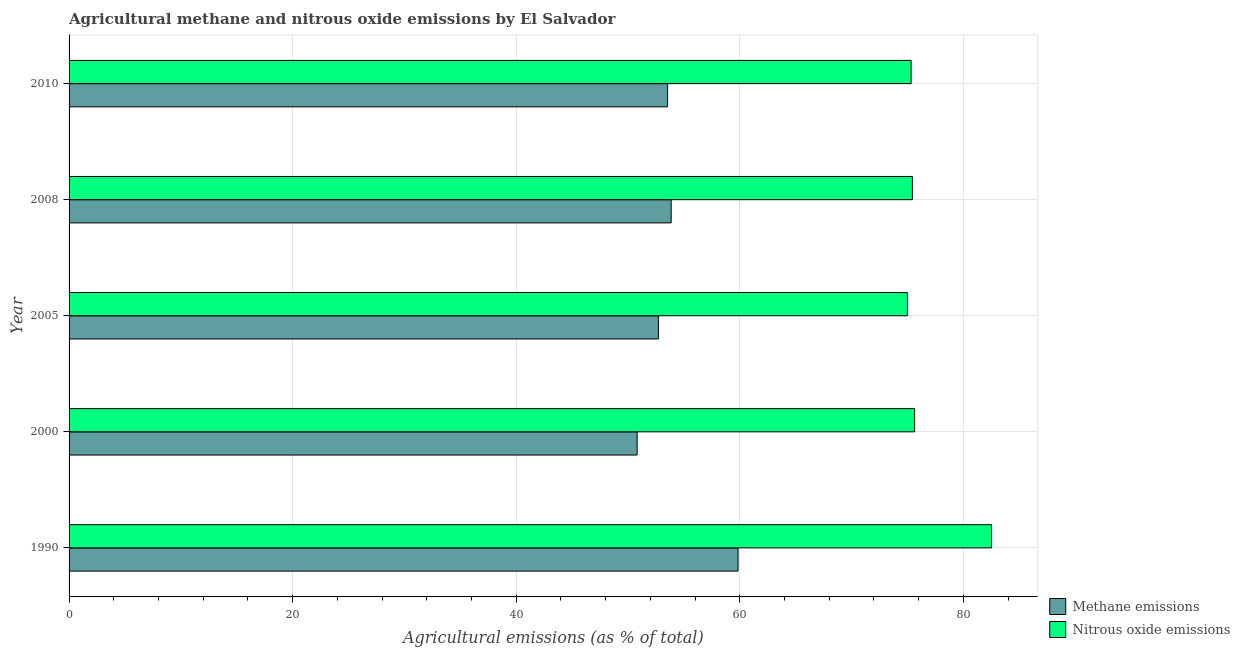How many groups of bars are there?
Provide a succinct answer. 5. Are the number of bars per tick equal to the number of legend labels?
Your response must be concise. Yes. Are the number of bars on each tick of the Y-axis equal?
Offer a very short reply. Yes. How many bars are there on the 3rd tick from the top?
Give a very brief answer. 2. What is the label of the 1st group of bars from the top?
Your response must be concise. 2010. In how many cases, is the number of bars for a given year not equal to the number of legend labels?
Your response must be concise. 0. What is the amount of methane emissions in 2010?
Your answer should be compact. 53.54. Across all years, what is the maximum amount of methane emissions?
Provide a short and direct response. 59.84. Across all years, what is the minimum amount of nitrous oxide emissions?
Offer a very short reply. 74.99. In which year was the amount of methane emissions minimum?
Offer a terse response. 2000. What is the total amount of nitrous oxide emissions in the graph?
Give a very brief answer. 383.91. What is the difference between the amount of nitrous oxide emissions in 2005 and the amount of methane emissions in 2008?
Give a very brief answer. 21.13. What is the average amount of methane emissions per year?
Your answer should be very brief. 54.16. In the year 2005, what is the difference between the amount of methane emissions and amount of nitrous oxide emissions?
Make the answer very short. -22.28. In how many years, is the amount of methane emissions greater than 20 %?
Your answer should be very brief. 5. What is the ratio of the amount of methane emissions in 1990 to that in 2010?
Offer a terse response. 1.12. Is the difference between the amount of nitrous oxide emissions in 1990 and 2010 greater than the difference between the amount of methane emissions in 1990 and 2010?
Keep it short and to the point. Yes. What is the difference between the highest and the second highest amount of methane emissions?
Your response must be concise. 5.98. What is the difference between the highest and the lowest amount of nitrous oxide emissions?
Offer a very short reply. 7.53. In how many years, is the amount of methane emissions greater than the average amount of methane emissions taken over all years?
Your answer should be compact. 1. Is the sum of the amount of methane emissions in 1990 and 2010 greater than the maximum amount of nitrous oxide emissions across all years?
Offer a terse response. Yes. What does the 2nd bar from the top in 2008 represents?
Offer a very short reply. Methane emissions. What does the 2nd bar from the bottom in 2000 represents?
Your answer should be very brief. Nitrous oxide emissions. Are the values on the major ticks of X-axis written in scientific E-notation?
Your response must be concise. No. Does the graph contain any zero values?
Provide a short and direct response. No. Does the graph contain grids?
Your response must be concise. Yes. How many legend labels are there?
Your answer should be compact. 2. How are the legend labels stacked?
Keep it short and to the point. Vertical. What is the title of the graph?
Your response must be concise. Agricultural methane and nitrous oxide emissions by El Salvador. Does "Foreign liabilities" appear as one of the legend labels in the graph?
Your answer should be compact. No. What is the label or title of the X-axis?
Your response must be concise. Agricultural emissions (as % of total). What is the label or title of the Y-axis?
Offer a very short reply. Year. What is the Agricultural emissions (as % of total) in Methane emissions in 1990?
Your response must be concise. 59.84. What is the Agricultural emissions (as % of total) of Nitrous oxide emissions in 1990?
Make the answer very short. 82.52. What is the Agricultural emissions (as % of total) in Methane emissions in 2000?
Ensure brevity in your answer.  50.82. What is the Agricultural emissions (as % of total) of Nitrous oxide emissions in 2000?
Ensure brevity in your answer.  75.64. What is the Agricultural emissions (as % of total) in Methane emissions in 2005?
Your answer should be very brief. 52.72. What is the Agricultural emissions (as % of total) of Nitrous oxide emissions in 2005?
Offer a very short reply. 74.99. What is the Agricultural emissions (as % of total) in Methane emissions in 2008?
Your answer should be compact. 53.86. What is the Agricultural emissions (as % of total) in Nitrous oxide emissions in 2008?
Offer a terse response. 75.44. What is the Agricultural emissions (as % of total) in Methane emissions in 2010?
Your answer should be very brief. 53.54. What is the Agricultural emissions (as % of total) of Nitrous oxide emissions in 2010?
Provide a short and direct response. 75.32. Across all years, what is the maximum Agricultural emissions (as % of total) in Methane emissions?
Your answer should be compact. 59.84. Across all years, what is the maximum Agricultural emissions (as % of total) in Nitrous oxide emissions?
Provide a succinct answer. 82.52. Across all years, what is the minimum Agricultural emissions (as % of total) in Methane emissions?
Offer a terse response. 50.82. Across all years, what is the minimum Agricultural emissions (as % of total) in Nitrous oxide emissions?
Offer a very short reply. 74.99. What is the total Agricultural emissions (as % of total) of Methane emissions in the graph?
Give a very brief answer. 270.78. What is the total Agricultural emissions (as % of total) in Nitrous oxide emissions in the graph?
Keep it short and to the point. 383.91. What is the difference between the Agricultural emissions (as % of total) of Methane emissions in 1990 and that in 2000?
Give a very brief answer. 9.02. What is the difference between the Agricultural emissions (as % of total) of Nitrous oxide emissions in 1990 and that in 2000?
Make the answer very short. 6.88. What is the difference between the Agricultural emissions (as % of total) in Methane emissions in 1990 and that in 2005?
Provide a succinct answer. 7.12. What is the difference between the Agricultural emissions (as % of total) in Nitrous oxide emissions in 1990 and that in 2005?
Give a very brief answer. 7.53. What is the difference between the Agricultural emissions (as % of total) of Methane emissions in 1990 and that in 2008?
Offer a terse response. 5.98. What is the difference between the Agricultural emissions (as % of total) of Nitrous oxide emissions in 1990 and that in 2008?
Ensure brevity in your answer.  7.09. What is the difference between the Agricultural emissions (as % of total) of Methane emissions in 1990 and that in 2010?
Offer a very short reply. 6.3. What is the difference between the Agricultural emissions (as % of total) in Nitrous oxide emissions in 1990 and that in 2010?
Provide a succinct answer. 7.2. What is the difference between the Agricultural emissions (as % of total) in Methane emissions in 2000 and that in 2005?
Keep it short and to the point. -1.9. What is the difference between the Agricultural emissions (as % of total) of Nitrous oxide emissions in 2000 and that in 2005?
Your answer should be very brief. 0.64. What is the difference between the Agricultural emissions (as % of total) in Methane emissions in 2000 and that in 2008?
Offer a very short reply. -3.04. What is the difference between the Agricultural emissions (as % of total) in Nitrous oxide emissions in 2000 and that in 2008?
Make the answer very short. 0.2. What is the difference between the Agricultural emissions (as % of total) in Methane emissions in 2000 and that in 2010?
Your answer should be very brief. -2.72. What is the difference between the Agricultural emissions (as % of total) in Nitrous oxide emissions in 2000 and that in 2010?
Your response must be concise. 0.32. What is the difference between the Agricultural emissions (as % of total) in Methane emissions in 2005 and that in 2008?
Offer a very short reply. -1.14. What is the difference between the Agricultural emissions (as % of total) in Nitrous oxide emissions in 2005 and that in 2008?
Provide a succinct answer. -0.44. What is the difference between the Agricultural emissions (as % of total) of Methane emissions in 2005 and that in 2010?
Your answer should be compact. -0.82. What is the difference between the Agricultural emissions (as % of total) of Nitrous oxide emissions in 2005 and that in 2010?
Offer a very short reply. -0.33. What is the difference between the Agricultural emissions (as % of total) of Methane emissions in 2008 and that in 2010?
Give a very brief answer. 0.32. What is the difference between the Agricultural emissions (as % of total) in Nitrous oxide emissions in 2008 and that in 2010?
Offer a terse response. 0.11. What is the difference between the Agricultural emissions (as % of total) of Methane emissions in 1990 and the Agricultural emissions (as % of total) of Nitrous oxide emissions in 2000?
Your response must be concise. -15.8. What is the difference between the Agricultural emissions (as % of total) in Methane emissions in 1990 and the Agricultural emissions (as % of total) in Nitrous oxide emissions in 2005?
Keep it short and to the point. -15.15. What is the difference between the Agricultural emissions (as % of total) of Methane emissions in 1990 and the Agricultural emissions (as % of total) of Nitrous oxide emissions in 2008?
Make the answer very short. -15.59. What is the difference between the Agricultural emissions (as % of total) of Methane emissions in 1990 and the Agricultural emissions (as % of total) of Nitrous oxide emissions in 2010?
Offer a very short reply. -15.48. What is the difference between the Agricultural emissions (as % of total) in Methane emissions in 2000 and the Agricultural emissions (as % of total) in Nitrous oxide emissions in 2005?
Offer a terse response. -24.18. What is the difference between the Agricultural emissions (as % of total) of Methane emissions in 2000 and the Agricultural emissions (as % of total) of Nitrous oxide emissions in 2008?
Offer a very short reply. -24.62. What is the difference between the Agricultural emissions (as % of total) of Methane emissions in 2000 and the Agricultural emissions (as % of total) of Nitrous oxide emissions in 2010?
Keep it short and to the point. -24.51. What is the difference between the Agricultural emissions (as % of total) in Methane emissions in 2005 and the Agricultural emissions (as % of total) in Nitrous oxide emissions in 2008?
Provide a succinct answer. -22.72. What is the difference between the Agricultural emissions (as % of total) of Methane emissions in 2005 and the Agricultural emissions (as % of total) of Nitrous oxide emissions in 2010?
Your answer should be very brief. -22.6. What is the difference between the Agricultural emissions (as % of total) of Methane emissions in 2008 and the Agricultural emissions (as % of total) of Nitrous oxide emissions in 2010?
Offer a terse response. -21.46. What is the average Agricultural emissions (as % of total) of Methane emissions per year?
Give a very brief answer. 54.16. What is the average Agricultural emissions (as % of total) of Nitrous oxide emissions per year?
Make the answer very short. 76.78. In the year 1990, what is the difference between the Agricultural emissions (as % of total) of Methane emissions and Agricultural emissions (as % of total) of Nitrous oxide emissions?
Your response must be concise. -22.68. In the year 2000, what is the difference between the Agricultural emissions (as % of total) of Methane emissions and Agricultural emissions (as % of total) of Nitrous oxide emissions?
Your response must be concise. -24.82. In the year 2005, what is the difference between the Agricultural emissions (as % of total) in Methane emissions and Agricultural emissions (as % of total) in Nitrous oxide emissions?
Give a very brief answer. -22.28. In the year 2008, what is the difference between the Agricultural emissions (as % of total) in Methane emissions and Agricultural emissions (as % of total) in Nitrous oxide emissions?
Your response must be concise. -21.57. In the year 2010, what is the difference between the Agricultural emissions (as % of total) in Methane emissions and Agricultural emissions (as % of total) in Nitrous oxide emissions?
Your answer should be compact. -21.78. What is the ratio of the Agricultural emissions (as % of total) in Methane emissions in 1990 to that in 2000?
Your response must be concise. 1.18. What is the ratio of the Agricultural emissions (as % of total) in Nitrous oxide emissions in 1990 to that in 2000?
Your answer should be very brief. 1.09. What is the ratio of the Agricultural emissions (as % of total) of Methane emissions in 1990 to that in 2005?
Provide a short and direct response. 1.14. What is the ratio of the Agricultural emissions (as % of total) in Nitrous oxide emissions in 1990 to that in 2005?
Offer a very short reply. 1.1. What is the ratio of the Agricultural emissions (as % of total) of Methane emissions in 1990 to that in 2008?
Provide a short and direct response. 1.11. What is the ratio of the Agricultural emissions (as % of total) of Nitrous oxide emissions in 1990 to that in 2008?
Your answer should be very brief. 1.09. What is the ratio of the Agricultural emissions (as % of total) in Methane emissions in 1990 to that in 2010?
Your answer should be very brief. 1.12. What is the ratio of the Agricultural emissions (as % of total) of Nitrous oxide emissions in 1990 to that in 2010?
Ensure brevity in your answer.  1.1. What is the ratio of the Agricultural emissions (as % of total) in Methane emissions in 2000 to that in 2005?
Keep it short and to the point. 0.96. What is the ratio of the Agricultural emissions (as % of total) in Nitrous oxide emissions in 2000 to that in 2005?
Your answer should be very brief. 1.01. What is the ratio of the Agricultural emissions (as % of total) of Methane emissions in 2000 to that in 2008?
Provide a succinct answer. 0.94. What is the ratio of the Agricultural emissions (as % of total) in Methane emissions in 2000 to that in 2010?
Offer a terse response. 0.95. What is the ratio of the Agricultural emissions (as % of total) in Methane emissions in 2005 to that in 2008?
Offer a terse response. 0.98. What is the ratio of the Agricultural emissions (as % of total) in Methane emissions in 2005 to that in 2010?
Ensure brevity in your answer.  0.98. What is the ratio of the Agricultural emissions (as % of total) of Nitrous oxide emissions in 2005 to that in 2010?
Your answer should be very brief. 1. What is the ratio of the Agricultural emissions (as % of total) of Nitrous oxide emissions in 2008 to that in 2010?
Offer a terse response. 1. What is the difference between the highest and the second highest Agricultural emissions (as % of total) of Methane emissions?
Give a very brief answer. 5.98. What is the difference between the highest and the second highest Agricultural emissions (as % of total) in Nitrous oxide emissions?
Keep it short and to the point. 6.88. What is the difference between the highest and the lowest Agricultural emissions (as % of total) in Methane emissions?
Your answer should be compact. 9.02. What is the difference between the highest and the lowest Agricultural emissions (as % of total) in Nitrous oxide emissions?
Offer a terse response. 7.53. 